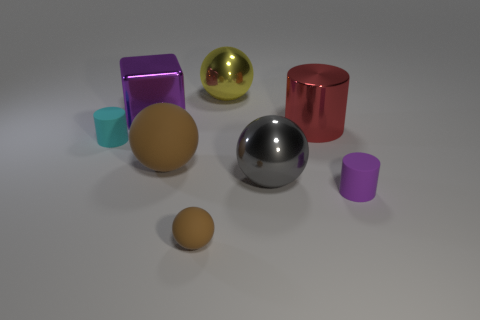There is a thing that is to the left of the large metallic thing to the left of the big brown sphere; what size is it?
Your answer should be very brief. Small. What number of metal cubes are the same color as the small sphere?
Keep it short and to the point. 0. What number of other things are the same size as the red metallic object?
Keep it short and to the point. 4. There is a cylinder that is right of the cyan cylinder and to the left of the small purple object; how big is it?
Offer a terse response. Large. How many brown things are the same shape as the gray metal thing?
Provide a short and direct response. 2. What is the material of the purple block?
Offer a very short reply. Metal. Is the shape of the yellow shiny object the same as the large gray metallic object?
Offer a very short reply. Yes. Is there a red object that has the same material as the block?
Ensure brevity in your answer.  Yes. What is the color of the large thing that is on the left side of the gray metal ball and in front of the shiny block?
Your answer should be very brief. Brown. What is the purple thing to the left of the tiny brown thing made of?
Make the answer very short. Metal. 